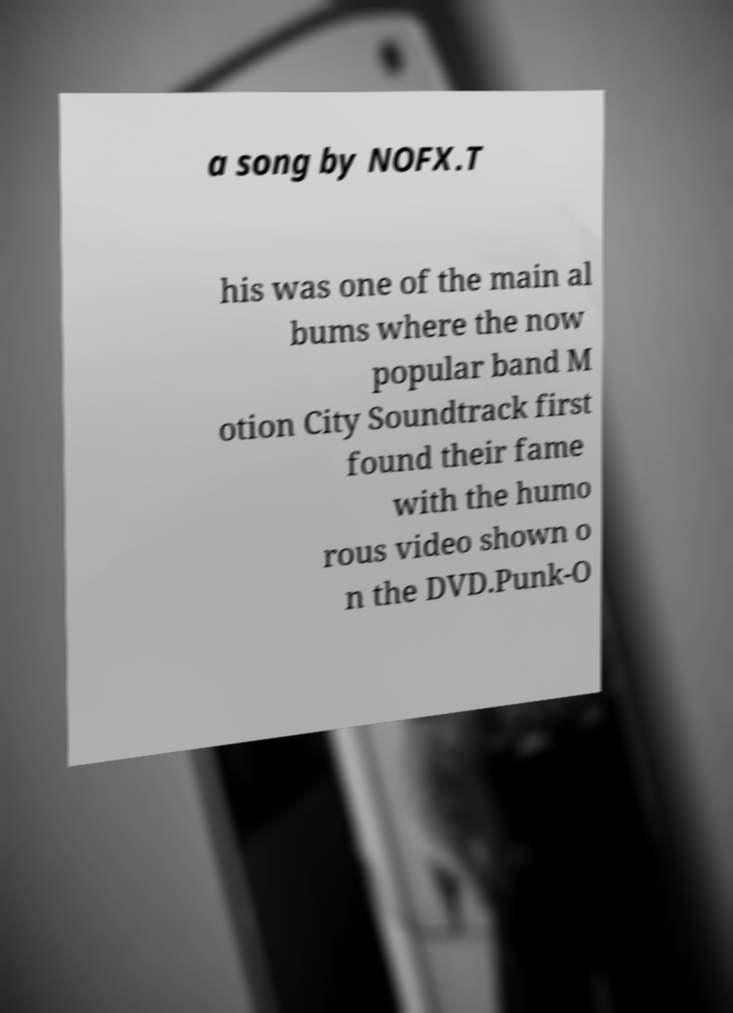There's text embedded in this image that I need extracted. Can you transcribe it verbatim? a song by NOFX.T his was one of the main al bums where the now popular band M otion City Soundtrack first found their fame with the humo rous video shown o n the DVD.Punk-O 